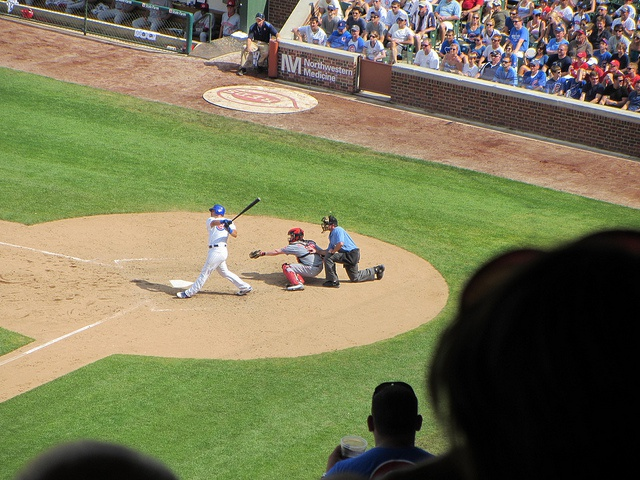Describe the objects in this image and their specific colors. I can see people in khaki, black, darkgreen, and olive tones, people in khaki, gray, black, brown, and lightgray tones, people in khaki, black, navy, gray, and olive tones, people in khaki, lightgray, darkgray, and tan tones, and people in khaki, gray, black, lightblue, and darkgray tones in this image. 